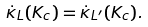Convert formula to latex. <formula><loc_0><loc_0><loc_500><loc_500>\dot { \kappa } _ { L } ( K _ { c } ) = \dot { \kappa } _ { L ^ { \prime } } ( K _ { c } ) .</formula> 